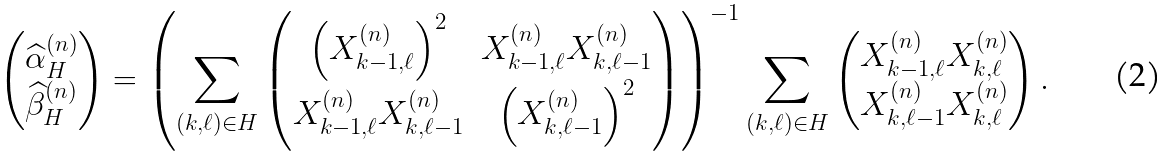Convert formula to latex. <formula><loc_0><loc_0><loc_500><loc_500>\begin{pmatrix} \widehat { \alpha } _ { H } ^ { ( n ) } \\ \widehat { \beta } _ { H } ^ { ( n ) } \end{pmatrix} = \left ( \sum _ { ( k , \ell ) \in H } \begin{pmatrix} \left ( X _ { k - 1 , \ell } ^ { ( n ) } \right ) ^ { 2 } & X _ { k - 1 , \ell } ^ { ( n ) } X _ { k , \ell - 1 } ^ { ( n ) } \\ X _ { k - 1 , \ell } ^ { ( n ) } X _ { k , \ell - 1 } ^ { ( n ) } & \left ( X _ { k , \ell - 1 } ^ { ( n ) } \right ) ^ { 2 } \end{pmatrix} \right ) ^ { - 1 } \sum _ { ( k , \ell ) \in H } \begin{pmatrix} X _ { k - 1 , \ell } ^ { ( n ) } X _ { k , \ell } ^ { ( n ) } \\ X _ { k , \ell - 1 } ^ { ( n ) } X _ { k , \ell } ^ { ( n ) } \end{pmatrix} .</formula> 